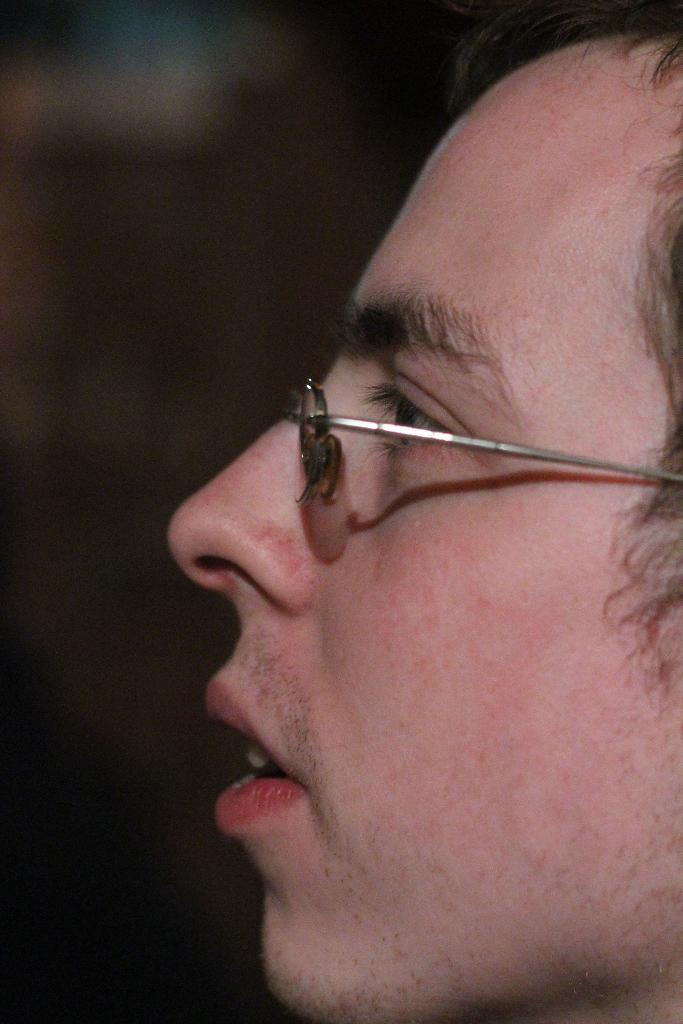Who is present in the image? There is a man in the picture. What accessory is the man wearing? The man is wearing spectacles. Can you describe the background of the image? The background of the image is blurry. What type of zinc structure can be seen in the background of the image? There is no zinc structure present in the image; the background is blurry. Where is the office located in the image? There is no office present in the image; it features a man wearing spectacles with a blurry background. 